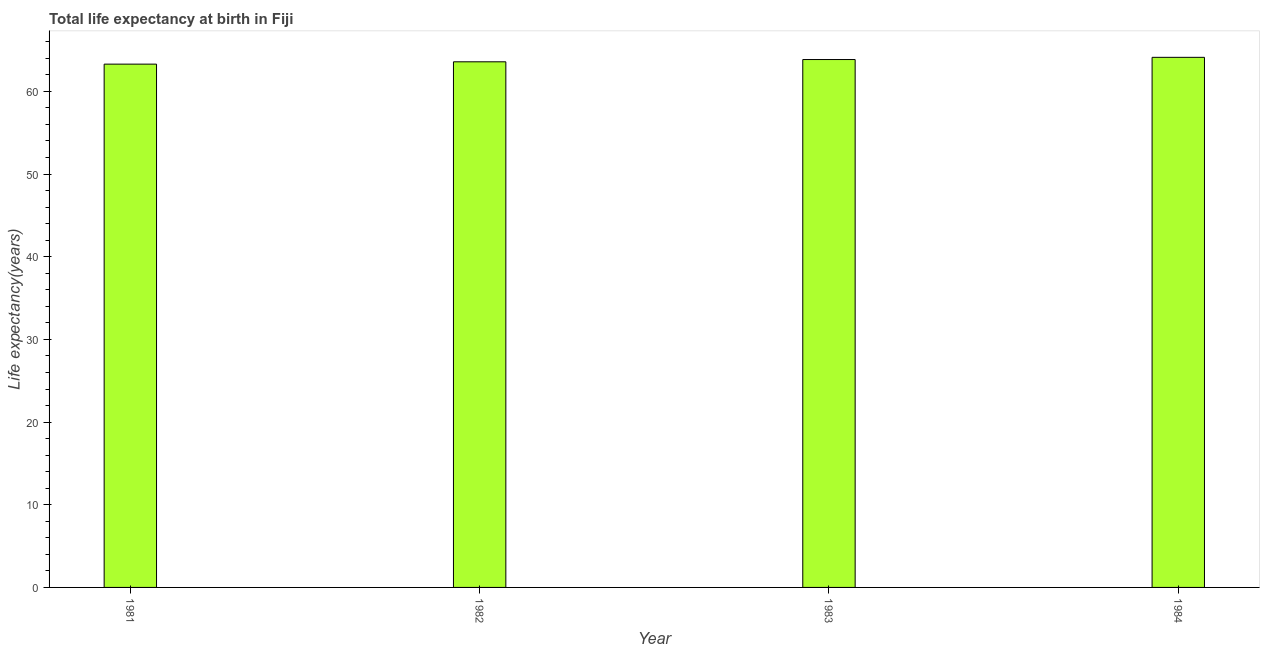Does the graph contain grids?
Your answer should be very brief. No. What is the title of the graph?
Offer a very short reply. Total life expectancy at birth in Fiji. What is the label or title of the X-axis?
Your answer should be compact. Year. What is the label or title of the Y-axis?
Your response must be concise. Life expectancy(years). What is the life expectancy at birth in 1984?
Provide a succinct answer. 64.12. Across all years, what is the maximum life expectancy at birth?
Offer a terse response. 64.12. Across all years, what is the minimum life expectancy at birth?
Ensure brevity in your answer.  63.3. In which year was the life expectancy at birth maximum?
Keep it short and to the point. 1984. In which year was the life expectancy at birth minimum?
Provide a succinct answer. 1981. What is the sum of the life expectancy at birth?
Your answer should be compact. 254.85. What is the difference between the life expectancy at birth in 1983 and 1984?
Provide a succinct answer. -0.27. What is the average life expectancy at birth per year?
Your response must be concise. 63.71. What is the median life expectancy at birth?
Offer a very short reply. 63.72. What is the difference between the highest and the second highest life expectancy at birth?
Offer a terse response. 0.27. What is the difference between the highest and the lowest life expectancy at birth?
Your answer should be compact. 0.82. In how many years, is the life expectancy at birth greater than the average life expectancy at birth taken over all years?
Give a very brief answer. 2. Are all the bars in the graph horizontal?
Your response must be concise. No. How many years are there in the graph?
Provide a short and direct response. 4. Are the values on the major ticks of Y-axis written in scientific E-notation?
Make the answer very short. No. What is the Life expectancy(years) of 1981?
Your answer should be very brief. 63.3. What is the Life expectancy(years) in 1982?
Your answer should be very brief. 63.58. What is the Life expectancy(years) of 1983?
Your response must be concise. 63.85. What is the Life expectancy(years) of 1984?
Your answer should be very brief. 64.12. What is the difference between the Life expectancy(years) in 1981 and 1982?
Offer a terse response. -0.28. What is the difference between the Life expectancy(years) in 1981 and 1983?
Offer a very short reply. -0.56. What is the difference between the Life expectancy(years) in 1981 and 1984?
Give a very brief answer. -0.82. What is the difference between the Life expectancy(years) in 1982 and 1983?
Offer a terse response. -0.28. What is the difference between the Life expectancy(years) in 1982 and 1984?
Keep it short and to the point. -0.54. What is the difference between the Life expectancy(years) in 1983 and 1984?
Make the answer very short. -0.27. What is the ratio of the Life expectancy(years) in 1981 to that in 1983?
Offer a very short reply. 0.99. What is the ratio of the Life expectancy(years) in 1983 to that in 1984?
Ensure brevity in your answer.  1. 